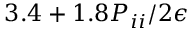Convert formula to latex. <formula><loc_0><loc_0><loc_500><loc_500>3 . 4 + 1 . 8 P _ { i i } / 2 \epsilon</formula> 